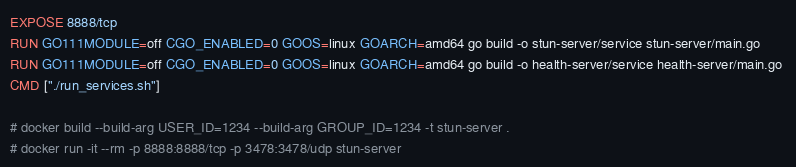Convert code to text. <code><loc_0><loc_0><loc_500><loc_500><_Dockerfile_>EXPOSE 8888/tcp
RUN GO111MODULE=off CGO_ENABLED=0 GOOS=linux GOARCH=amd64 go build -o stun-server/service stun-server/main.go 
RUN GO111MODULE=off CGO_ENABLED=0 GOOS=linux GOARCH=amd64 go build -o health-server/service health-server/main.go 
CMD ["./run_services.sh"]

# docker build --build-arg USER_ID=1234 --build-arg GROUP_ID=1234 -t stun-server .
# docker run -it --rm -p 8888:8888/tcp -p 3478:3478/udp stun-server
</code> 